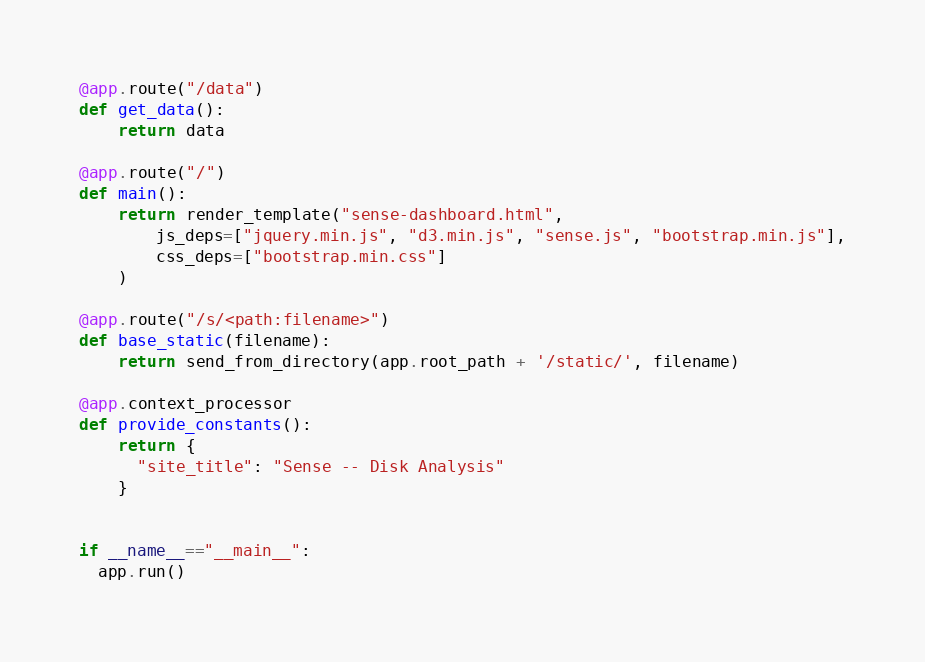Convert code to text. <code><loc_0><loc_0><loc_500><loc_500><_Python_>
@app.route("/data")
def get_data():
    return data

@app.route("/")
def main():
    return render_template("sense-dashboard.html",
        js_deps=["jquery.min.js", "d3.min.js", "sense.js", "bootstrap.min.js"],
        css_deps=["bootstrap.min.css"]
    )

@app.route("/s/<path:filename>")
def base_static(filename):
    return send_from_directory(app.root_path + '/static/', filename)

@app.context_processor
def provide_constants():
    return {
      "site_title": "Sense -- Disk Analysis"
    }


if __name__=="__main__":
  app.run()
</code> 